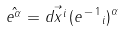Convert formula to latex. <formula><loc_0><loc_0><loc_500><loc_500>\hat { e ^ { \alpha } } = \vec { d x ^ { i } } \, ( { e ^ { \, - \, 1 } } _ { i } ) ^ { \alpha }</formula> 